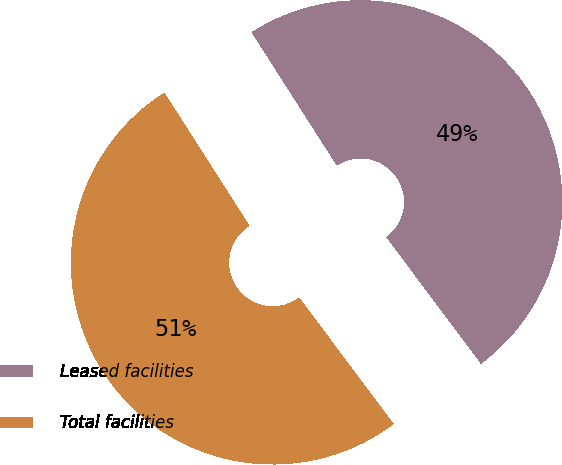Convert chart. <chart><loc_0><loc_0><loc_500><loc_500><pie_chart><fcel>Leased facilities<fcel>Total facilities<nl><fcel>48.84%<fcel>51.16%<nl></chart> 